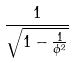<formula> <loc_0><loc_0><loc_500><loc_500>\frac { 1 } { \sqrt { 1 - \frac { 1 } { \phi ^ { 2 } } } }</formula> 